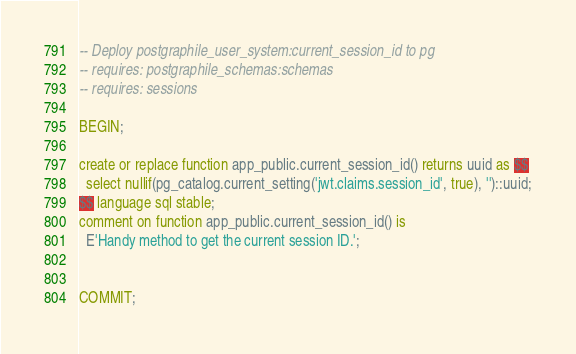Convert code to text. <code><loc_0><loc_0><loc_500><loc_500><_SQL_>-- Deploy postgraphile_user_system:current_session_id to pg
-- requires: postgraphile_schemas:schemas
-- requires: sessions

BEGIN;

create or replace function app_public.current_session_id() returns uuid as $$
  select nullif(pg_catalog.current_setting('jwt.claims.session_id', true), '')::uuid;
$$ language sql stable;
comment on function app_public.current_session_id() is
  E'Handy method to get the current session ID.';


COMMIT;
</code> 